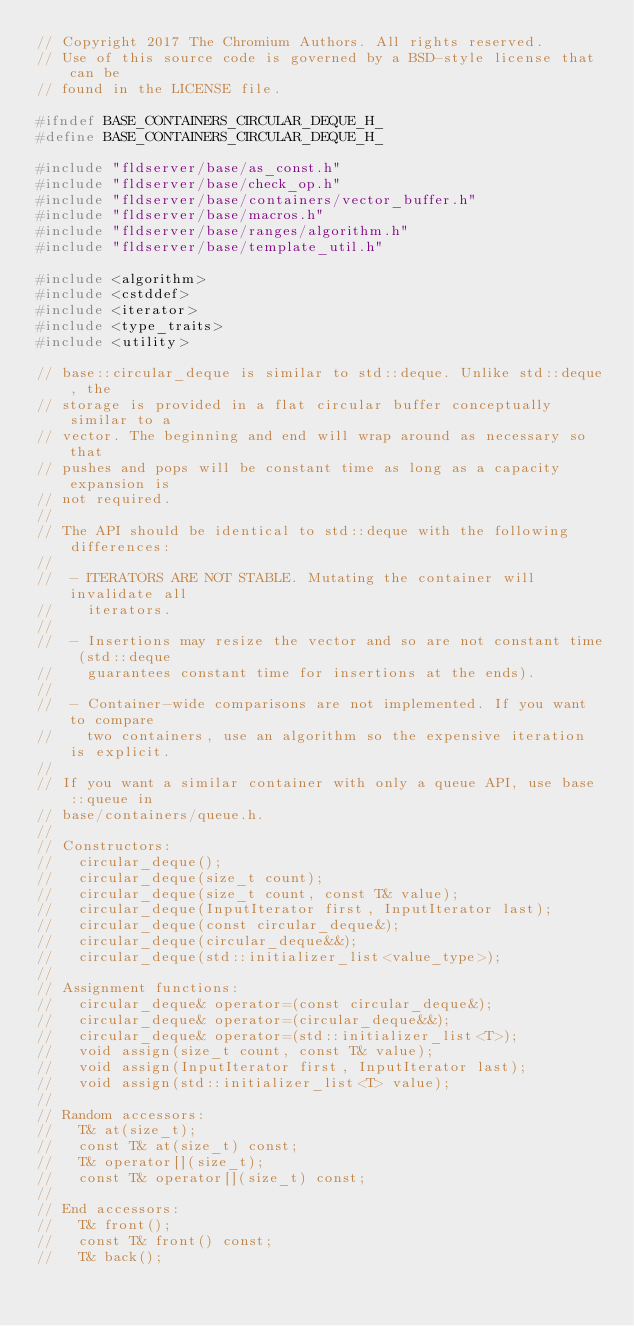<code> <loc_0><loc_0><loc_500><loc_500><_C_>// Copyright 2017 The Chromium Authors. All rights reserved.
// Use of this source code is governed by a BSD-style license that can be
// found in the LICENSE file.

#ifndef BASE_CONTAINERS_CIRCULAR_DEQUE_H_
#define BASE_CONTAINERS_CIRCULAR_DEQUE_H_

#include "fldserver/base/as_const.h"
#include "fldserver/base/check_op.h"
#include "fldserver/base/containers/vector_buffer.h"
#include "fldserver/base/macros.h"
#include "fldserver/base/ranges/algorithm.h"
#include "fldserver/base/template_util.h"

#include <algorithm>
#include <cstddef>
#include <iterator>
#include <type_traits>
#include <utility>

// base::circular_deque is similar to std::deque. Unlike std::deque, the
// storage is provided in a flat circular buffer conceptually similar to a
// vector. The beginning and end will wrap around as necessary so that
// pushes and pops will be constant time as long as a capacity expansion is
// not required.
//
// The API should be identical to std::deque with the following differences:
//
//  - ITERATORS ARE NOT STABLE. Mutating the container will invalidate all
//    iterators.
//
//  - Insertions may resize the vector and so are not constant time (std::deque
//    guarantees constant time for insertions at the ends).
//
//  - Container-wide comparisons are not implemented. If you want to compare
//    two containers, use an algorithm so the expensive iteration is explicit.
//
// If you want a similar container with only a queue API, use base::queue in
// base/containers/queue.h.
//
// Constructors:
//   circular_deque();
//   circular_deque(size_t count);
//   circular_deque(size_t count, const T& value);
//   circular_deque(InputIterator first, InputIterator last);
//   circular_deque(const circular_deque&);
//   circular_deque(circular_deque&&);
//   circular_deque(std::initializer_list<value_type>);
//
// Assignment functions:
//   circular_deque& operator=(const circular_deque&);
//   circular_deque& operator=(circular_deque&&);
//   circular_deque& operator=(std::initializer_list<T>);
//   void assign(size_t count, const T& value);
//   void assign(InputIterator first, InputIterator last);
//   void assign(std::initializer_list<T> value);
//
// Random accessors:
//   T& at(size_t);
//   const T& at(size_t) const;
//   T& operator[](size_t);
//   const T& operator[](size_t) const;
//
// End accessors:
//   T& front();
//   const T& front() const;
//   T& back();</code> 